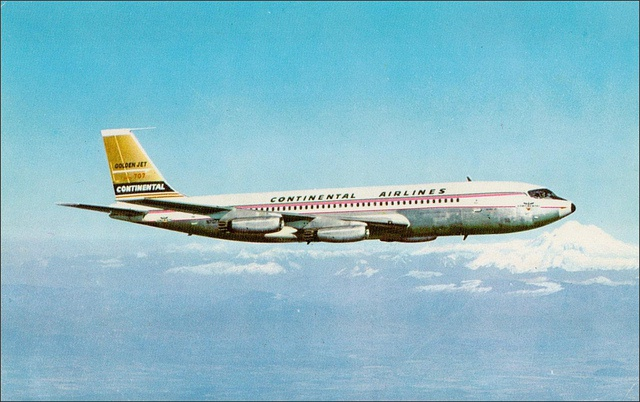Describe the objects in this image and their specific colors. I can see a airplane in black, ivory, darkgray, and gray tones in this image. 